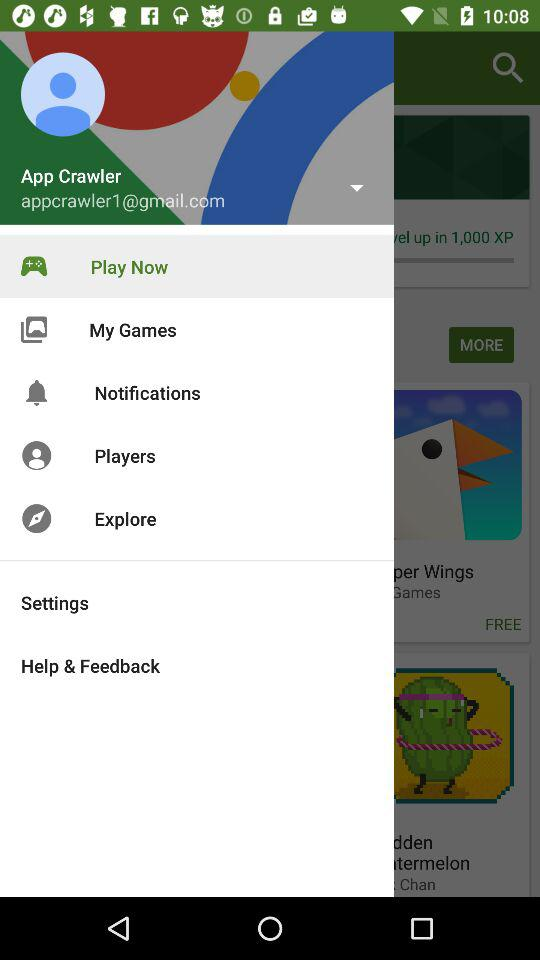What is the email address? The email address is appcrawler1@gmail.com. 